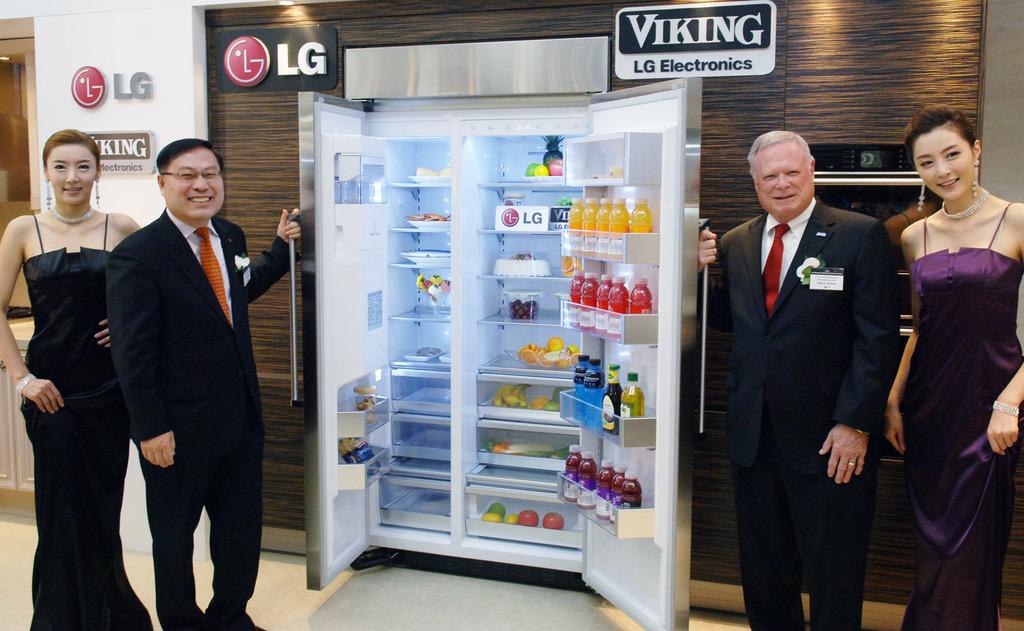Who makes this fridge?
Make the answer very short. Lg. Which two letters are in white next to the red circle?
Your response must be concise. Lg. 